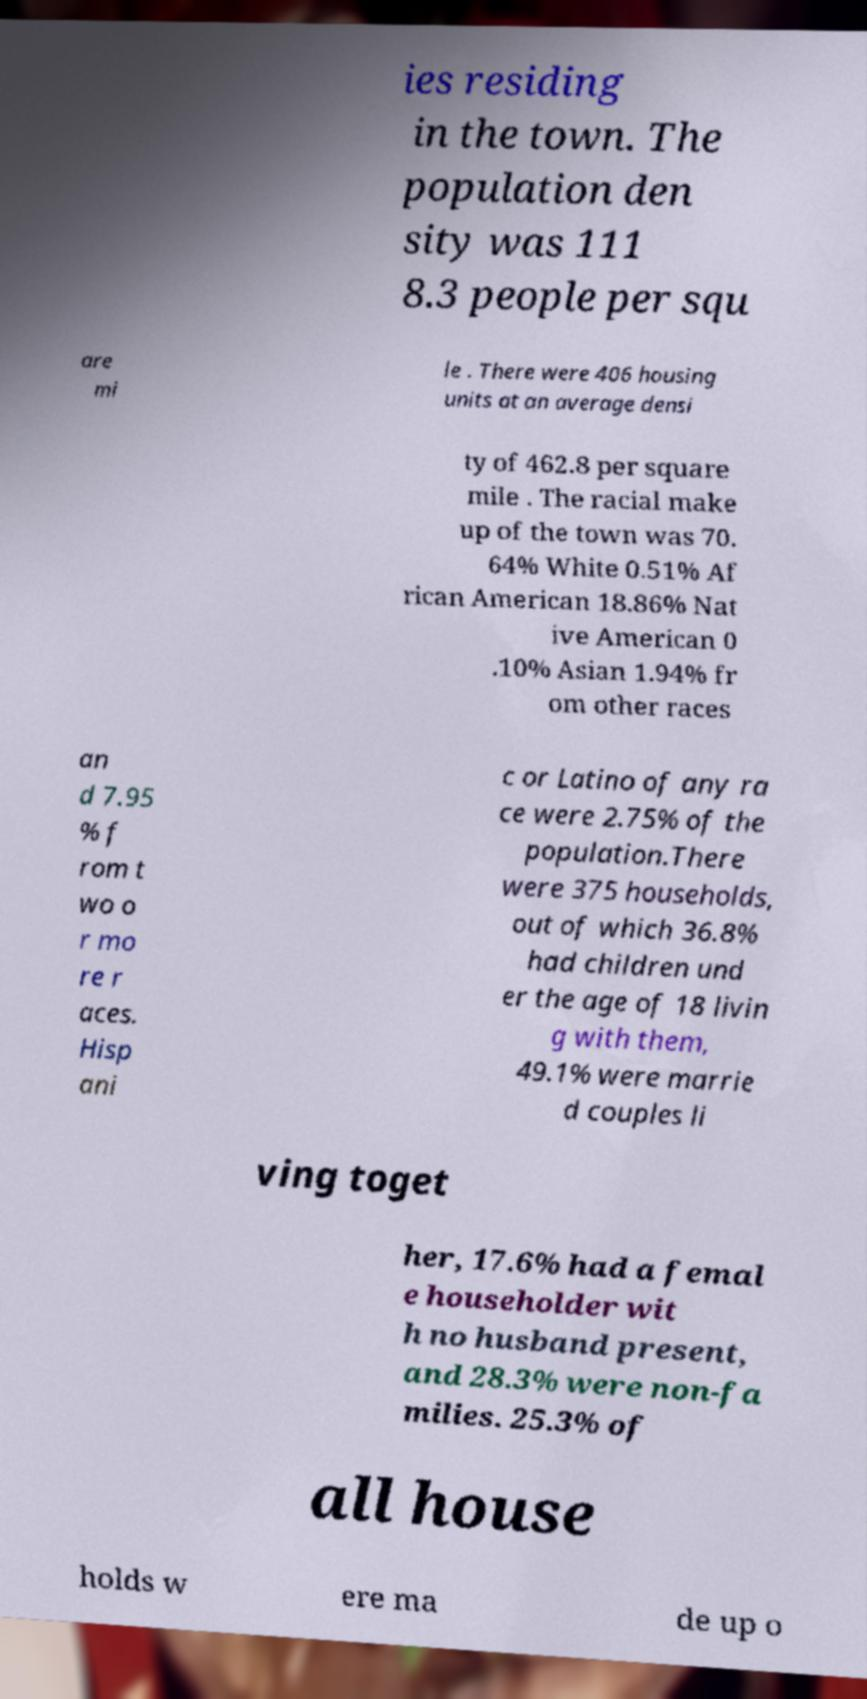Can you accurately transcribe the text from the provided image for me? ies residing in the town. The population den sity was 111 8.3 people per squ are mi le . There were 406 housing units at an average densi ty of 462.8 per square mile . The racial make up of the town was 70. 64% White 0.51% Af rican American 18.86% Nat ive American 0 .10% Asian 1.94% fr om other races an d 7.95 % f rom t wo o r mo re r aces. Hisp ani c or Latino of any ra ce were 2.75% of the population.There were 375 households, out of which 36.8% had children und er the age of 18 livin g with them, 49.1% were marrie d couples li ving toget her, 17.6% had a femal e householder wit h no husband present, and 28.3% were non-fa milies. 25.3% of all house holds w ere ma de up o 